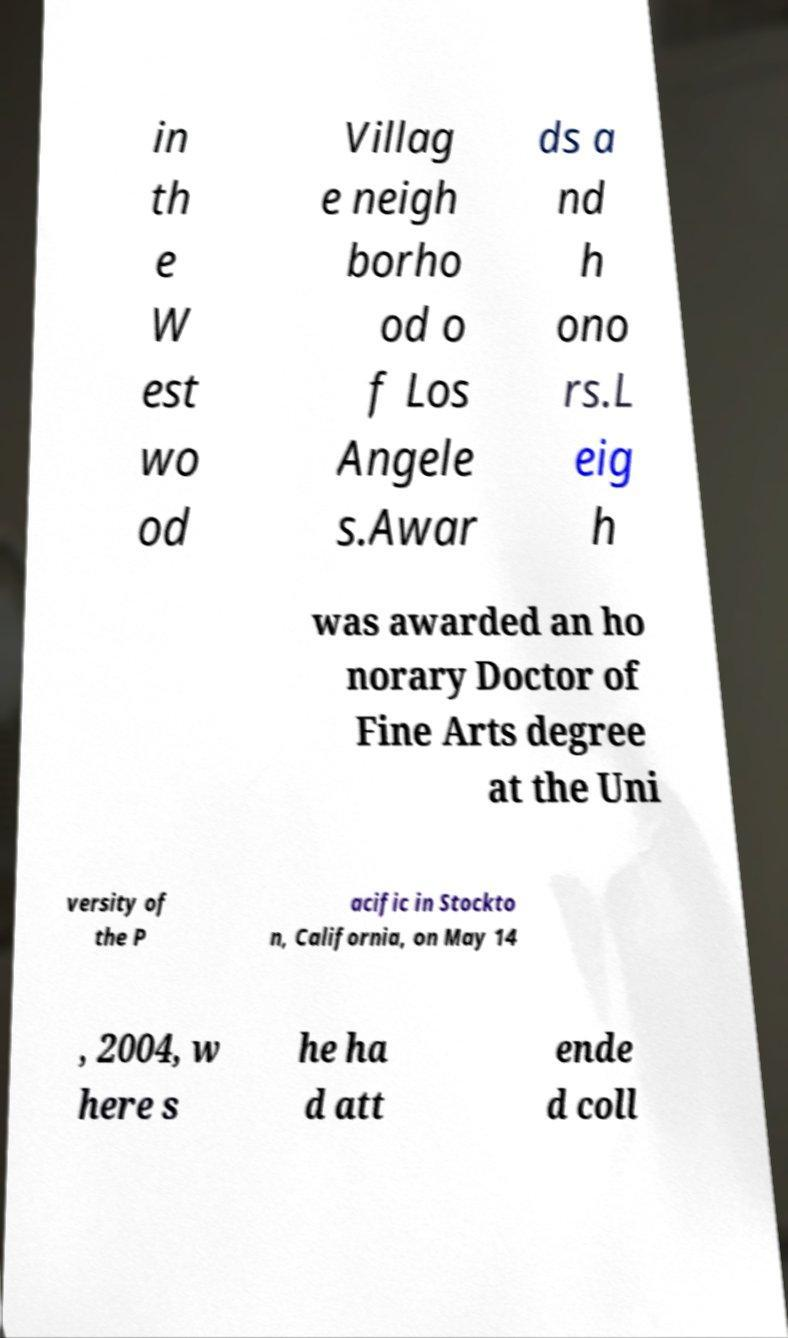Please identify and transcribe the text found in this image. in th e W est wo od Villag e neigh borho od o f Los Angele s.Awar ds a nd h ono rs.L eig h was awarded an ho norary Doctor of Fine Arts degree at the Uni versity of the P acific in Stockto n, California, on May 14 , 2004, w here s he ha d att ende d coll 